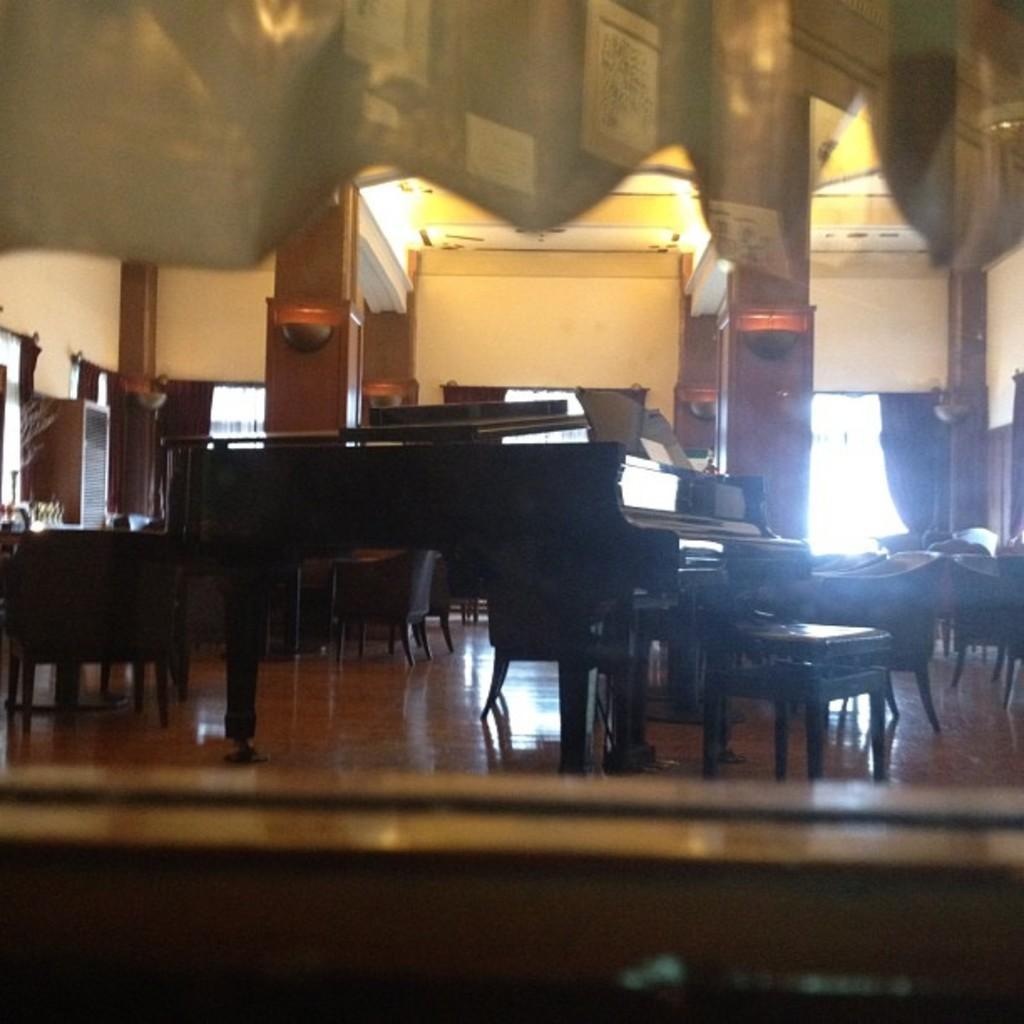Please provide a concise description of this image. There is a room. There is a table and chair in a room. we can see in background pillar ,wall,cupboard and window. 